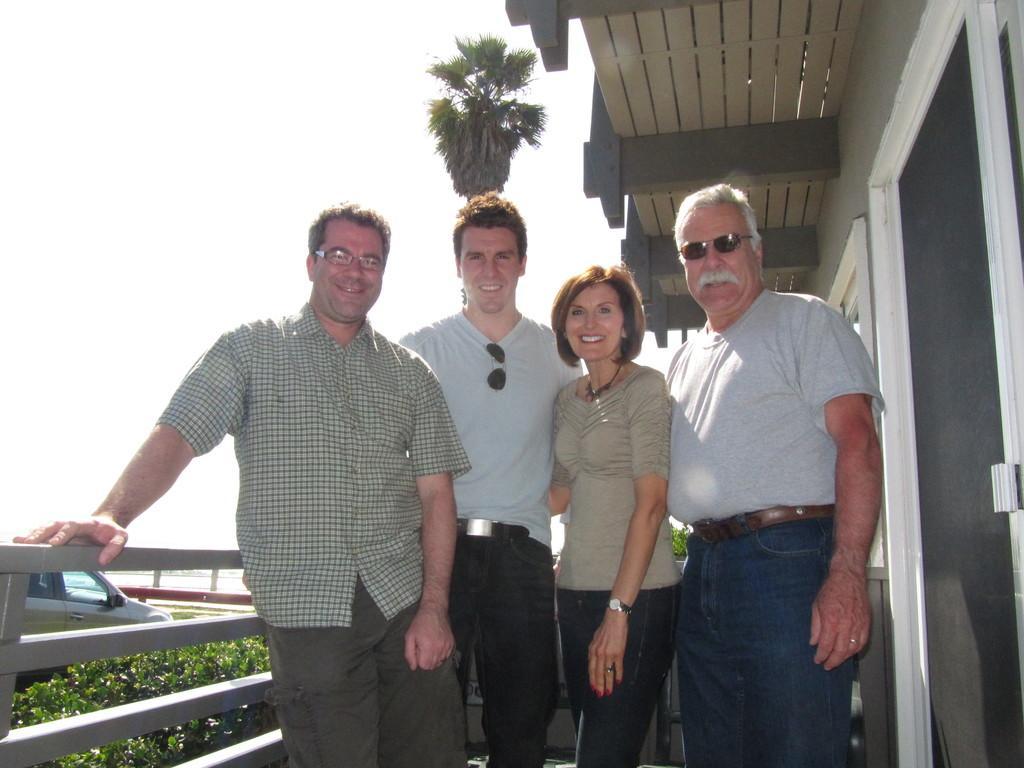Describe this image in one or two sentences. In this image there are four persons standing on the floor. Beside them there is a fence. On the right side there is a building. In the background there is a car which is parked on the road. Beside the car there are plants. At the top there is the sky. 